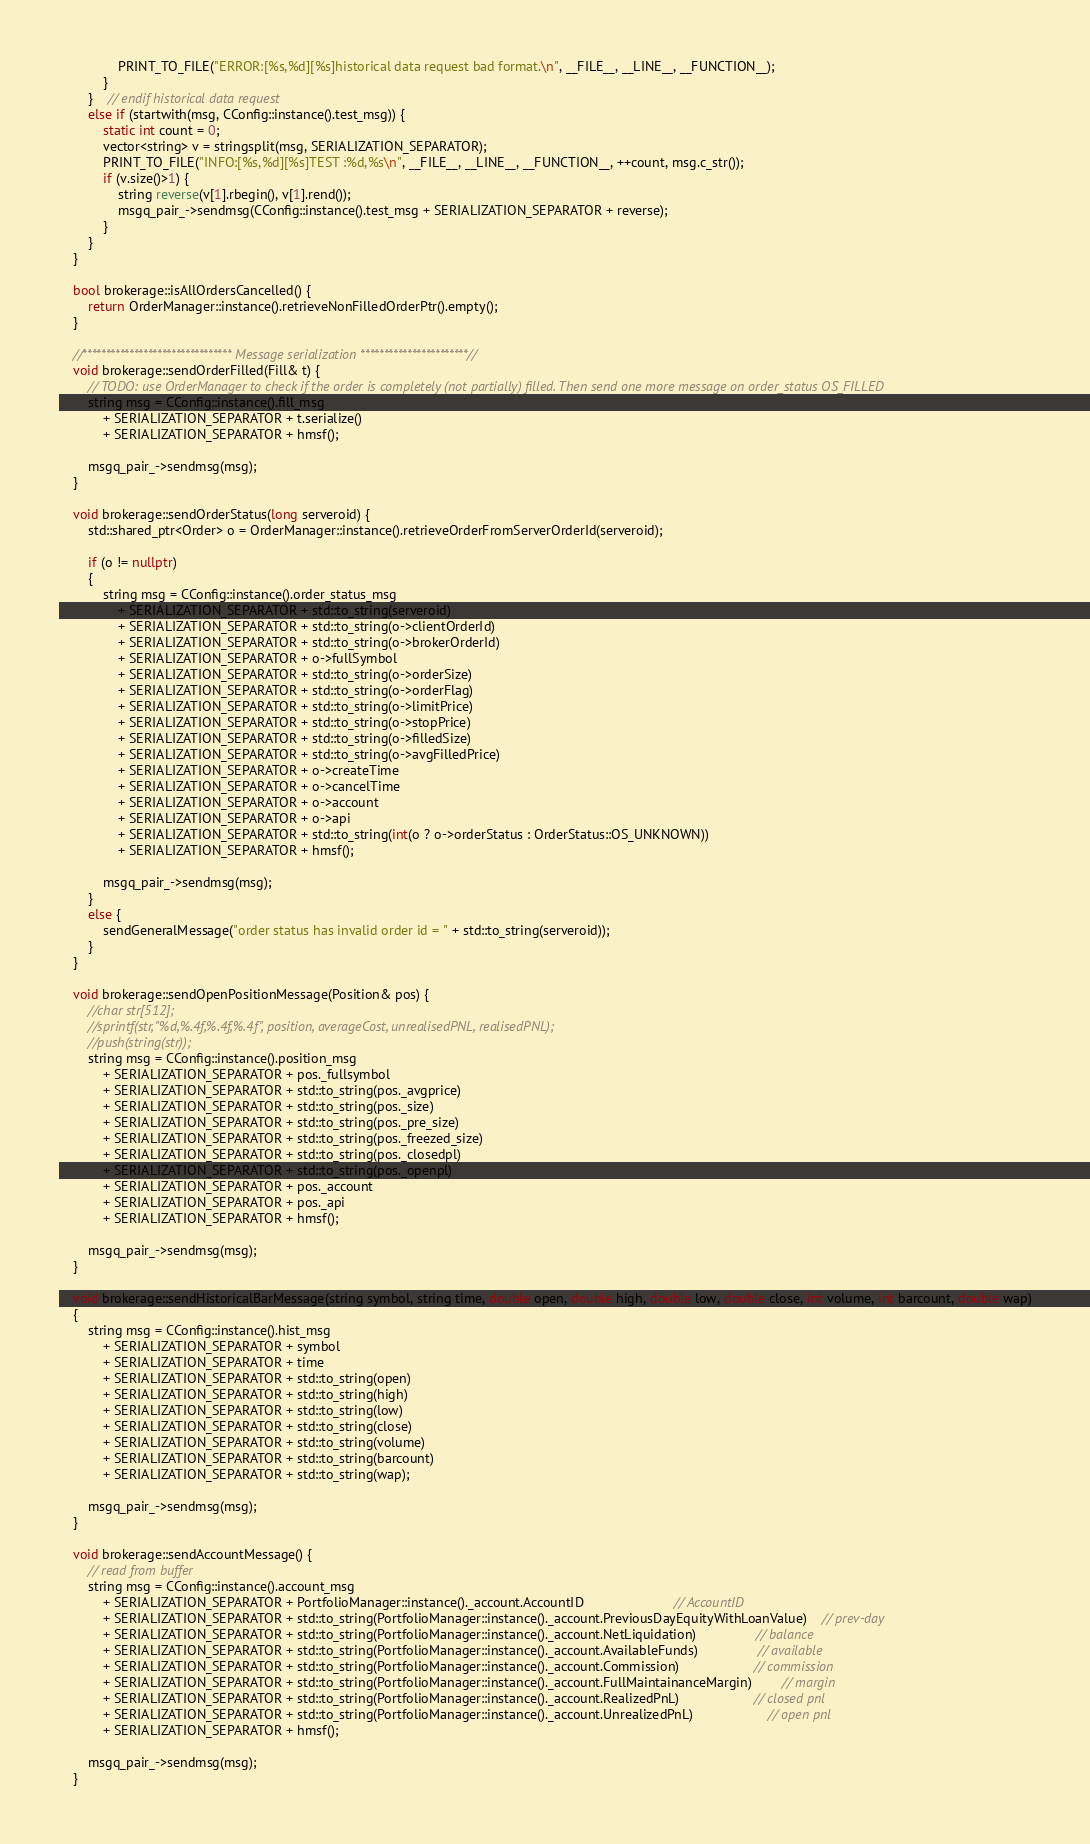<code> <loc_0><loc_0><loc_500><loc_500><_C++_>				PRINT_TO_FILE("ERROR:[%s,%d][%s]historical data request bad format.\n", __FILE__, __LINE__, __FUNCTION__);
			}
		}	// endif historical data request
		else if (startwith(msg, CConfig::instance().test_msg)) {
			static int count = 0;
			vector<string> v = stringsplit(msg, SERIALIZATION_SEPARATOR);
			PRINT_TO_FILE("INFO:[%s,%d][%s]TEST :%d,%s\n", __FILE__, __LINE__, __FUNCTION__, ++count, msg.c_str());
			if (v.size()>1) {
				string reverse(v[1].rbegin(), v[1].rend());
				msgq_pair_->sendmsg(CConfig::instance().test_msg + SERIALIZATION_SEPARATOR + reverse);
			}
		}
	}

	bool brokerage::isAllOrdersCancelled() {
		return OrderManager::instance().retrieveNonFilledOrderPtr().empty();
	}

	//******************************** Message serialization ***********************//
	void brokerage::sendOrderFilled(Fill& t) {
		// TODO: use OrderManager to check if the order is completely (not partially) filled. Then send one more message on order_status OS_FILLED
		string msg = CConfig::instance().fill_msg
			+ SERIALIZATION_SEPARATOR + t.serialize()
			+ SERIALIZATION_SEPARATOR + hmsf();

		msgq_pair_->sendmsg(msg);
	}

	void brokerage::sendOrderStatus(long serveroid) {
		std::shared_ptr<Order> o = OrderManager::instance().retrieveOrderFromServerOrderId(serveroid);

		if (o != nullptr)
		{
			string msg = CConfig::instance().order_status_msg
				+ SERIALIZATION_SEPARATOR + std::to_string(serveroid)
				+ SERIALIZATION_SEPARATOR + std::to_string(o->clientOrderId)
				+ SERIALIZATION_SEPARATOR + std::to_string(o->brokerOrderId)
				+ SERIALIZATION_SEPARATOR + o->fullSymbol
				+ SERIALIZATION_SEPARATOR + std::to_string(o->orderSize)
				+ SERIALIZATION_SEPARATOR + std::to_string(o->orderFlag)
				+ SERIALIZATION_SEPARATOR + std::to_string(o->limitPrice)
				+ SERIALIZATION_SEPARATOR + std::to_string(o->stopPrice)
				+ SERIALIZATION_SEPARATOR + std::to_string(o->filledSize)
				+ SERIALIZATION_SEPARATOR + std::to_string(o->avgFilledPrice)
				+ SERIALIZATION_SEPARATOR + o->createTime
				+ SERIALIZATION_SEPARATOR + o->cancelTime
				+ SERIALIZATION_SEPARATOR + o->account
				+ SERIALIZATION_SEPARATOR + o->api
				+ SERIALIZATION_SEPARATOR + std::to_string(int(o ? o->orderStatus : OrderStatus::OS_UNKNOWN))
				+ SERIALIZATION_SEPARATOR + hmsf();

			msgq_pair_->sendmsg(msg);
		}
		else {
			sendGeneralMessage("order status has invalid order id = " + std::to_string(serveroid));
		}
	}

	void brokerage::sendOpenPositionMessage(Position& pos) {
		//char str[512];
		//sprintf(str, "%d,%.4f,%.4f,%.4f", position, averageCost, unrealisedPNL, realisedPNL);
		//push(string(str));
		string msg = CConfig::instance().position_msg
			+ SERIALIZATION_SEPARATOR + pos._fullsymbol
			+ SERIALIZATION_SEPARATOR + std::to_string(pos._avgprice)
			+ SERIALIZATION_SEPARATOR + std::to_string(pos._size)
			+ SERIALIZATION_SEPARATOR + std::to_string(pos._pre_size)
			+ SERIALIZATION_SEPARATOR + std::to_string(pos._freezed_size)
			+ SERIALIZATION_SEPARATOR + std::to_string(pos._closedpl)
			+ SERIALIZATION_SEPARATOR + std::to_string(pos._openpl)
			+ SERIALIZATION_SEPARATOR + pos._account
			+ SERIALIZATION_SEPARATOR + pos._api
			+ SERIALIZATION_SEPARATOR + hmsf();

		msgq_pair_->sendmsg(msg);
	}

	void brokerage::sendHistoricalBarMessage(string symbol, string time, double open, double high, double low, double close, int volume, int barcount, double wap)
	{
		string msg = CConfig::instance().hist_msg
			+ SERIALIZATION_SEPARATOR + symbol
			+ SERIALIZATION_SEPARATOR + time
			+ SERIALIZATION_SEPARATOR + std::to_string(open)
			+ SERIALIZATION_SEPARATOR + std::to_string(high)
			+ SERIALIZATION_SEPARATOR + std::to_string(low)
			+ SERIALIZATION_SEPARATOR + std::to_string(close)
			+ SERIALIZATION_SEPARATOR + std::to_string(volume)
			+ SERIALIZATION_SEPARATOR + std::to_string(barcount)
			+ SERIALIZATION_SEPARATOR + std::to_string(wap);

		msgq_pair_->sendmsg(msg);
	}

	void brokerage::sendAccountMessage() {
		// read from buffer
		string msg = CConfig::instance().account_msg
			+ SERIALIZATION_SEPARATOR + PortfolioManager::instance()._account.AccountID						// AccountID
			+ SERIALIZATION_SEPARATOR + std::to_string(PortfolioManager::instance()._account.PreviousDayEquityWithLoanValue)	// prev-day
			+ SERIALIZATION_SEPARATOR + std::to_string(PortfolioManager::instance()._account.NetLiquidation)				// balance
			+ SERIALIZATION_SEPARATOR + std::to_string(PortfolioManager::instance()._account.AvailableFunds)				// available
			+ SERIALIZATION_SEPARATOR + std::to_string(PortfolioManager::instance()._account.Commission)					// commission
			+ SERIALIZATION_SEPARATOR + std::to_string(PortfolioManager::instance()._account.FullMaintainanceMargin)		// margin
			+ SERIALIZATION_SEPARATOR + std::to_string(PortfolioManager::instance()._account.RealizedPnL)					// closed pnl
			+ SERIALIZATION_SEPARATOR + std::to_string(PortfolioManager::instance()._account.UnrealizedPnL)					// open pnl
			+ SERIALIZATION_SEPARATOR + hmsf();

		msgq_pair_->sendmsg(msg);
	}
</code> 